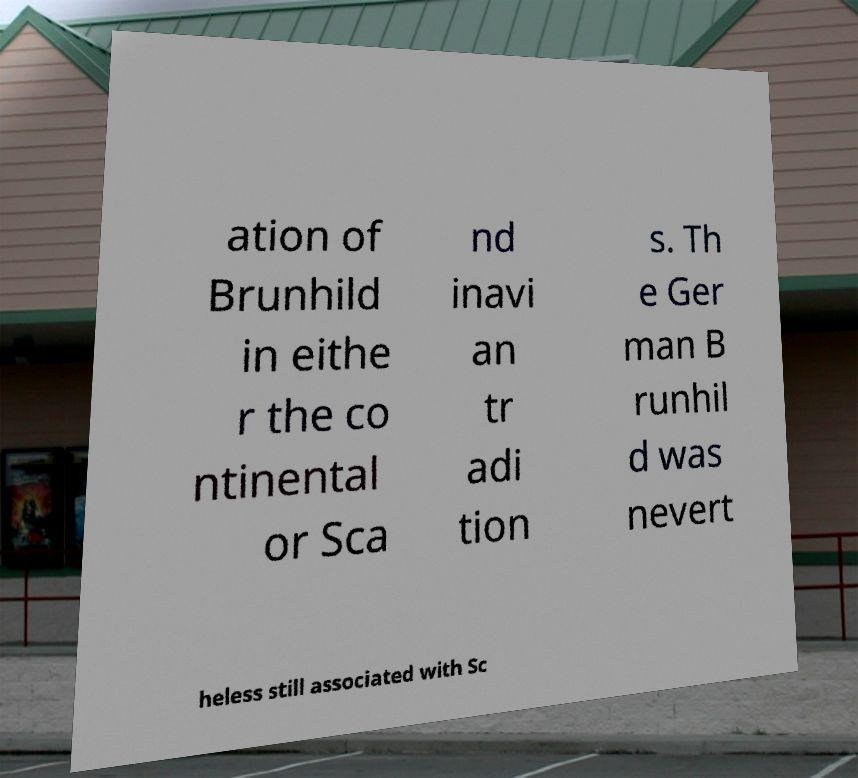Can you accurately transcribe the text from the provided image for me? ation of Brunhild in eithe r the co ntinental or Sca nd inavi an tr adi tion s. Th e Ger man B runhil d was nevert heless still associated with Sc 